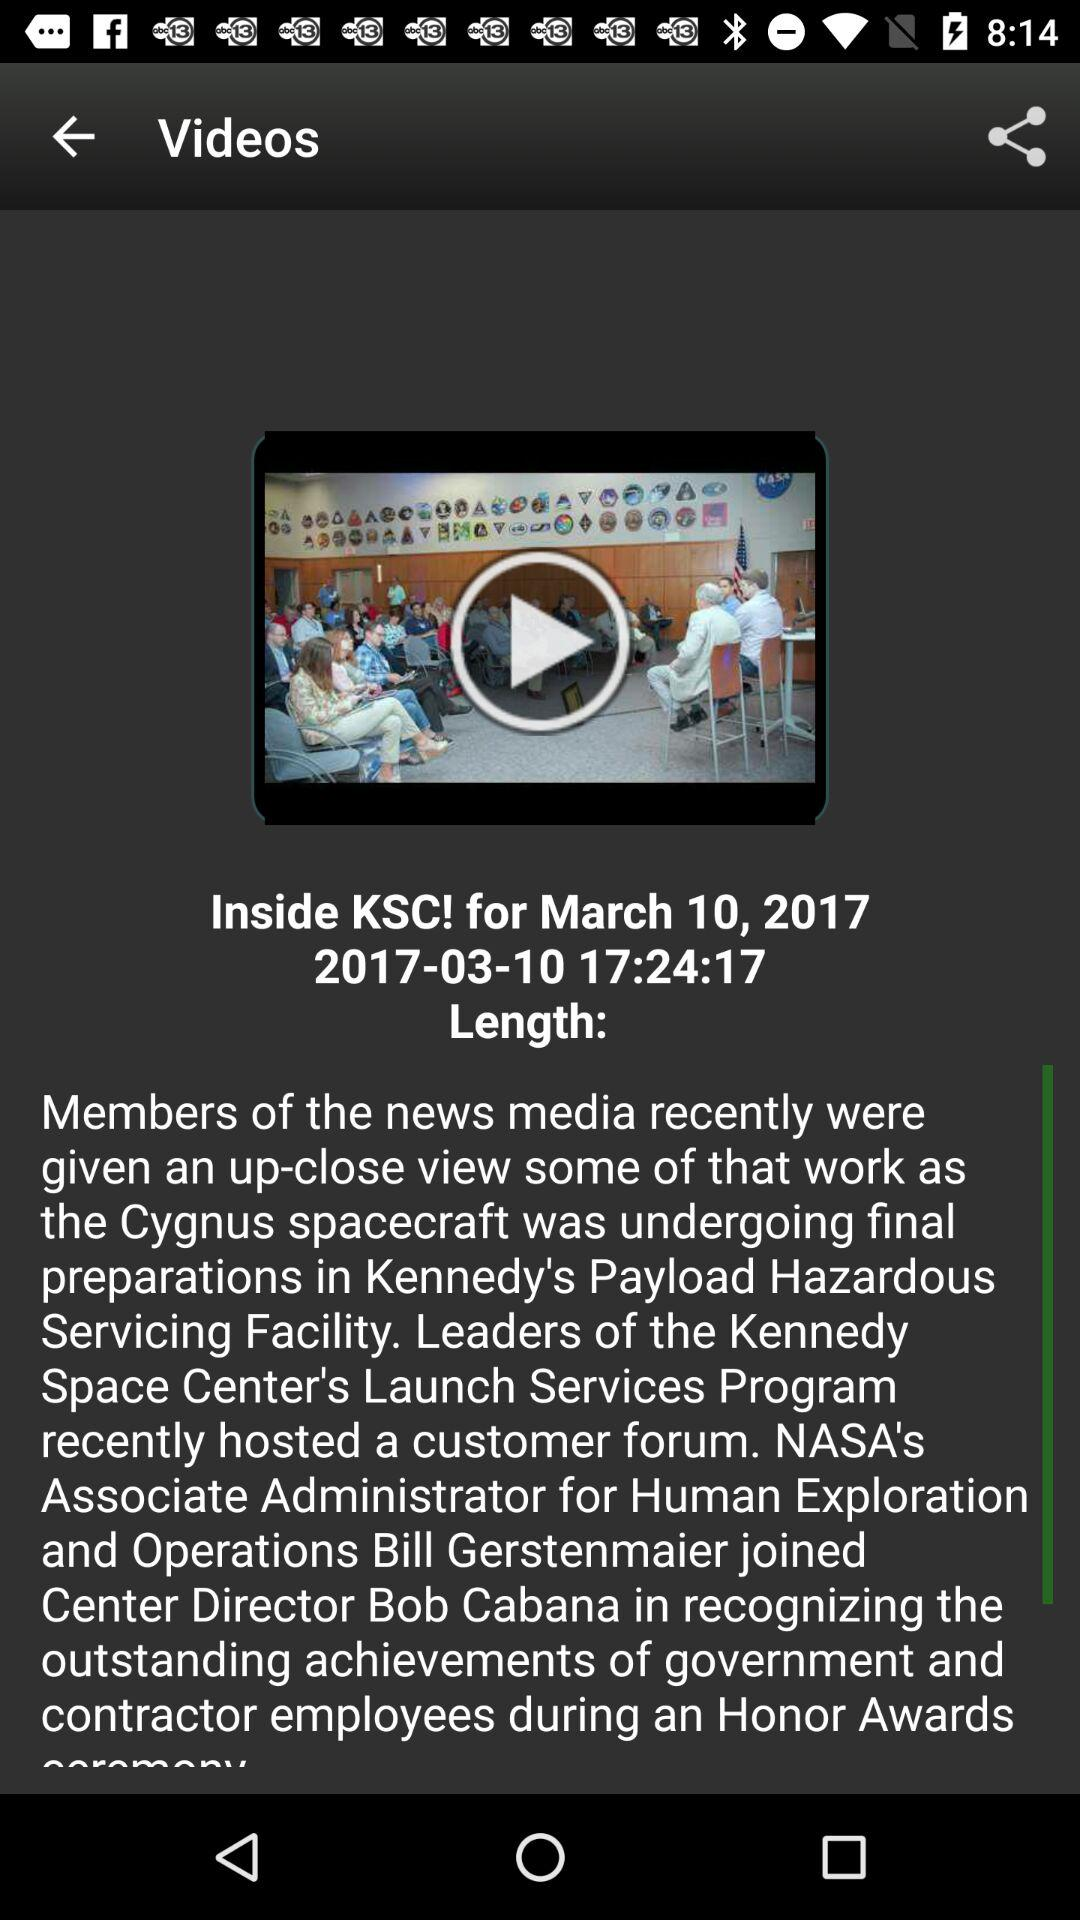What is the video publication date? The video publication date is March 10, 2017. 